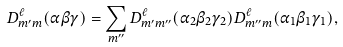Convert formula to latex. <formula><loc_0><loc_0><loc_500><loc_500>D _ { m ^ { \prime } m } ^ { \ell } ( \alpha \beta \gamma ) = \sum _ { m ^ { \prime \prime } } D _ { m ^ { \prime } m ^ { \prime \prime } } ^ { \ell } ( \alpha _ { 2 } \beta _ { 2 } \gamma _ { 2 } ) D _ { m ^ { \prime \prime } m } ^ { \ell } ( \alpha _ { 1 } \beta _ { 1 } \gamma _ { 1 } ) ,</formula> 